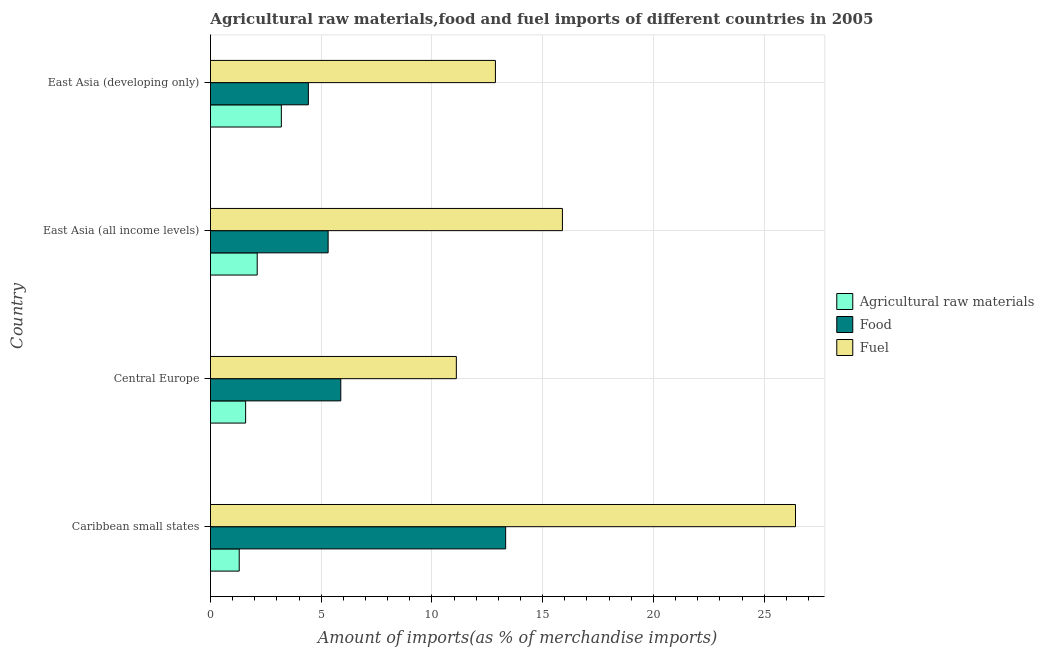Are the number of bars per tick equal to the number of legend labels?
Provide a succinct answer. Yes. How many bars are there on the 3rd tick from the top?
Offer a terse response. 3. How many bars are there on the 3rd tick from the bottom?
Give a very brief answer. 3. What is the label of the 3rd group of bars from the top?
Your answer should be very brief. Central Europe. In how many cases, is the number of bars for a given country not equal to the number of legend labels?
Your answer should be compact. 0. What is the percentage of raw materials imports in Central Europe?
Your response must be concise. 1.59. Across all countries, what is the maximum percentage of fuel imports?
Offer a terse response. 26.41. Across all countries, what is the minimum percentage of raw materials imports?
Your answer should be very brief. 1.3. In which country was the percentage of fuel imports maximum?
Give a very brief answer. Caribbean small states. In which country was the percentage of fuel imports minimum?
Give a very brief answer. Central Europe. What is the total percentage of raw materials imports in the graph?
Give a very brief answer. 8.19. What is the difference between the percentage of raw materials imports in East Asia (all income levels) and that in East Asia (developing only)?
Give a very brief answer. -1.09. What is the difference between the percentage of food imports in Central Europe and the percentage of raw materials imports in East Asia (developing only)?
Make the answer very short. 2.68. What is the average percentage of food imports per country?
Your response must be concise. 7.24. What is the difference between the percentage of food imports and percentage of fuel imports in Central Europe?
Give a very brief answer. -5.22. What is the ratio of the percentage of food imports in Caribbean small states to that in East Asia (developing only)?
Give a very brief answer. 3.02. What is the difference between the highest and the second highest percentage of food imports?
Provide a short and direct response. 7.45. What is the difference between the highest and the lowest percentage of raw materials imports?
Offer a very short reply. 1.9. In how many countries, is the percentage of fuel imports greater than the average percentage of fuel imports taken over all countries?
Ensure brevity in your answer.  1. Is the sum of the percentage of raw materials imports in Central Europe and East Asia (developing only) greater than the maximum percentage of fuel imports across all countries?
Your answer should be compact. No. What does the 2nd bar from the top in East Asia (developing only) represents?
Your answer should be very brief. Food. What does the 3rd bar from the bottom in Caribbean small states represents?
Your answer should be compact. Fuel. Are all the bars in the graph horizontal?
Provide a short and direct response. Yes. How many countries are there in the graph?
Keep it short and to the point. 4. Are the values on the major ticks of X-axis written in scientific E-notation?
Offer a terse response. No. Where does the legend appear in the graph?
Provide a succinct answer. Center right. What is the title of the graph?
Provide a succinct answer. Agricultural raw materials,food and fuel imports of different countries in 2005. What is the label or title of the X-axis?
Give a very brief answer. Amount of imports(as % of merchandise imports). What is the label or title of the Y-axis?
Your answer should be compact. Country. What is the Amount of imports(as % of merchandise imports) of Agricultural raw materials in Caribbean small states?
Make the answer very short. 1.3. What is the Amount of imports(as % of merchandise imports) of Food in Caribbean small states?
Your answer should be compact. 13.33. What is the Amount of imports(as % of merchandise imports) of Fuel in Caribbean small states?
Your response must be concise. 26.41. What is the Amount of imports(as % of merchandise imports) of Agricultural raw materials in Central Europe?
Your answer should be very brief. 1.59. What is the Amount of imports(as % of merchandise imports) of Food in Central Europe?
Ensure brevity in your answer.  5.88. What is the Amount of imports(as % of merchandise imports) in Fuel in Central Europe?
Provide a short and direct response. 11.1. What is the Amount of imports(as % of merchandise imports) of Agricultural raw materials in East Asia (all income levels)?
Make the answer very short. 2.11. What is the Amount of imports(as % of merchandise imports) in Food in East Asia (all income levels)?
Provide a succinct answer. 5.31. What is the Amount of imports(as % of merchandise imports) in Fuel in East Asia (all income levels)?
Your response must be concise. 15.89. What is the Amount of imports(as % of merchandise imports) of Agricultural raw materials in East Asia (developing only)?
Your response must be concise. 3.2. What is the Amount of imports(as % of merchandise imports) of Food in East Asia (developing only)?
Your answer should be very brief. 4.42. What is the Amount of imports(as % of merchandise imports) in Fuel in East Asia (developing only)?
Your answer should be compact. 12.87. Across all countries, what is the maximum Amount of imports(as % of merchandise imports) of Agricultural raw materials?
Provide a short and direct response. 3.2. Across all countries, what is the maximum Amount of imports(as % of merchandise imports) in Food?
Provide a short and direct response. 13.33. Across all countries, what is the maximum Amount of imports(as % of merchandise imports) of Fuel?
Provide a succinct answer. 26.41. Across all countries, what is the minimum Amount of imports(as % of merchandise imports) of Agricultural raw materials?
Provide a short and direct response. 1.3. Across all countries, what is the minimum Amount of imports(as % of merchandise imports) of Food?
Offer a terse response. 4.42. Across all countries, what is the minimum Amount of imports(as % of merchandise imports) in Fuel?
Your response must be concise. 11.1. What is the total Amount of imports(as % of merchandise imports) of Agricultural raw materials in the graph?
Provide a succinct answer. 8.19. What is the total Amount of imports(as % of merchandise imports) in Food in the graph?
Your response must be concise. 28.94. What is the total Amount of imports(as % of merchandise imports) in Fuel in the graph?
Your answer should be very brief. 66.27. What is the difference between the Amount of imports(as % of merchandise imports) of Agricultural raw materials in Caribbean small states and that in Central Europe?
Provide a succinct answer. -0.29. What is the difference between the Amount of imports(as % of merchandise imports) in Food in Caribbean small states and that in Central Europe?
Provide a succinct answer. 7.44. What is the difference between the Amount of imports(as % of merchandise imports) in Fuel in Caribbean small states and that in Central Europe?
Keep it short and to the point. 15.31. What is the difference between the Amount of imports(as % of merchandise imports) of Agricultural raw materials in Caribbean small states and that in East Asia (all income levels)?
Provide a succinct answer. -0.81. What is the difference between the Amount of imports(as % of merchandise imports) of Food in Caribbean small states and that in East Asia (all income levels)?
Offer a very short reply. 8.02. What is the difference between the Amount of imports(as % of merchandise imports) in Fuel in Caribbean small states and that in East Asia (all income levels)?
Your response must be concise. 10.52. What is the difference between the Amount of imports(as % of merchandise imports) of Agricultural raw materials in Caribbean small states and that in East Asia (developing only)?
Provide a succinct answer. -1.9. What is the difference between the Amount of imports(as % of merchandise imports) of Food in Caribbean small states and that in East Asia (developing only)?
Keep it short and to the point. 8.91. What is the difference between the Amount of imports(as % of merchandise imports) in Fuel in Caribbean small states and that in East Asia (developing only)?
Give a very brief answer. 13.55. What is the difference between the Amount of imports(as % of merchandise imports) of Agricultural raw materials in Central Europe and that in East Asia (all income levels)?
Provide a short and direct response. -0.52. What is the difference between the Amount of imports(as % of merchandise imports) of Food in Central Europe and that in East Asia (all income levels)?
Provide a short and direct response. 0.57. What is the difference between the Amount of imports(as % of merchandise imports) in Fuel in Central Europe and that in East Asia (all income levels)?
Offer a very short reply. -4.79. What is the difference between the Amount of imports(as % of merchandise imports) in Agricultural raw materials in Central Europe and that in East Asia (developing only)?
Provide a succinct answer. -1.61. What is the difference between the Amount of imports(as % of merchandise imports) of Food in Central Europe and that in East Asia (developing only)?
Make the answer very short. 1.46. What is the difference between the Amount of imports(as % of merchandise imports) in Fuel in Central Europe and that in East Asia (developing only)?
Make the answer very short. -1.76. What is the difference between the Amount of imports(as % of merchandise imports) in Agricultural raw materials in East Asia (all income levels) and that in East Asia (developing only)?
Make the answer very short. -1.09. What is the difference between the Amount of imports(as % of merchandise imports) in Food in East Asia (all income levels) and that in East Asia (developing only)?
Your answer should be compact. 0.89. What is the difference between the Amount of imports(as % of merchandise imports) in Fuel in East Asia (all income levels) and that in East Asia (developing only)?
Give a very brief answer. 3.03. What is the difference between the Amount of imports(as % of merchandise imports) of Agricultural raw materials in Caribbean small states and the Amount of imports(as % of merchandise imports) of Food in Central Europe?
Give a very brief answer. -4.59. What is the difference between the Amount of imports(as % of merchandise imports) in Agricultural raw materials in Caribbean small states and the Amount of imports(as % of merchandise imports) in Fuel in Central Europe?
Offer a terse response. -9.8. What is the difference between the Amount of imports(as % of merchandise imports) in Food in Caribbean small states and the Amount of imports(as % of merchandise imports) in Fuel in Central Europe?
Give a very brief answer. 2.23. What is the difference between the Amount of imports(as % of merchandise imports) in Agricultural raw materials in Caribbean small states and the Amount of imports(as % of merchandise imports) in Food in East Asia (all income levels)?
Make the answer very short. -4.01. What is the difference between the Amount of imports(as % of merchandise imports) of Agricultural raw materials in Caribbean small states and the Amount of imports(as % of merchandise imports) of Fuel in East Asia (all income levels)?
Offer a very short reply. -14.59. What is the difference between the Amount of imports(as % of merchandise imports) of Food in Caribbean small states and the Amount of imports(as % of merchandise imports) of Fuel in East Asia (all income levels)?
Your answer should be very brief. -2.56. What is the difference between the Amount of imports(as % of merchandise imports) in Agricultural raw materials in Caribbean small states and the Amount of imports(as % of merchandise imports) in Food in East Asia (developing only)?
Offer a terse response. -3.12. What is the difference between the Amount of imports(as % of merchandise imports) in Agricultural raw materials in Caribbean small states and the Amount of imports(as % of merchandise imports) in Fuel in East Asia (developing only)?
Give a very brief answer. -11.57. What is the difference between the Amount of imports(as % of merchandise imports) in Food in Caribbean small states and the Amount of imports(as % of merchandise imports) in Fuel in East Asia (developing only)?
Your response must be concise. 0.46. What is the difference between the Amount of imports(as % of merchandise imports) in Agricultural raw materials in Central Europe and the Amount of imports(as % of merchandise imports) in Food in East Asia (all income levels)?
Ensure brevity in your answer.  -3.73. What is the difference between the Amount of imports(as % of merchandise imports) in Agricultural raw materials in Central Europe and the Amount of imports(as % of merchandise imports) in Fuel in East Asia (all income levels)?
Ensure brevity in your answer.  -14.3. What is the difference between the Amount of imports(as % of merchandise imports) in Food in Central Europe and the Amount of imports(as % of merchandise imports) in Fuel in East Asia (all income levels)?
Offer a terse response. -10.01. What is the difference between the Amount of imports(as % of merchandise imports) of Agricultural raw materials in Central Europe and the Amount of imports(as % of merchandise imports) of Food in East Asia (developing only)?
Your response must be concise. -2.83. What is the difference between the Amount of imports(as % of merchandise imports) in Agricultural raw materials in Central Europe and the Amount of imports(as % of merchandise imports) in Fuel in East Asia (developing only)?
Provide a short and direct response. -11.28. What is the difference between the Amount of imports(as % of merchandise imports) in Food in Central Europe and the Amount of imports(as % of merchandise imports) in Fuel in East Asia (developing only)?
Provide a succinct answer. -6.98. What is the difference between the Amount of imports(as % of merchandise imports) in Agricultural raw materials in East Asia (all income levels) and the Amount of imports(as % of merchandise imports) in Food in East Asia (developing only)?
Your answer should be compact. -2.31. What is the difference between the Amount of imports(as % of merchandise imports) in Agricultural raw materials in East Asia (all income levels) and the Amount of imports(as % of merchandise imports) in Fuel in East Asia (developing only)?
Your response must be concise. -10.76. What is the difference between the Amount of imports(as % of merchandise imports) in Food in East Asia (all income levels) and the Amount of imports(as % of merchandise imports) in Fuel in East Asia (developing only)?
Your answer should be compact. -7.55. What is the average Amount of imports(as % of merchandise imports) in Agricultural raw materials per country?
Keep it short and to the point. 2.05. What is the average Amount of imports(as % of merchandise imports) of Food per country?
Provide a short and direct response. 7.24. What is the average Amount of imports(as % of merchandise imports) in Fuel per country?
Provide a short and direct response. 16.57. What is the difference between the Amount of imports(as % of merchandise imports) in Agricultural raw materials and Amount of imports(as % of merchandise imports) in Food in Caribbean small states?
Provide a succinct answer. -12.03. What is the difference between the Amount of imports(as % of merchandise imports) in Agricultural raw materials and Amount of imports(as % of merchandise imports) in Fuel in Caribbean small states?
Your answer should be very brief. -25.12. What is the difference between the Amount of imports(as % of merchandise imports) of Food and Amount of imports(as % of merchandise imports) of Fuel in Caribbean small states?
Your answer should be very brief. -13.09. What is the difference between the Amount of imports(as % of merchandise imports) of Agricultural raw materials and Amount of imports(as % of merchandise imports) of Food in Central Europe?
Provide a succinct answer. -4.3. What is the difference between the Amount of imports(as % of merchandise imports) of Agricultural raw materials and Amount of imports(as % of merchandise imports) of Fuel in Central Europe?
Provide a short and direct response. -9.51. What is the difference between the Amount of imports(as % of merchandise imports) in Food and Amount of imports(as % of merchandise imports) in Fuel in Central Europe?
Your answer should be very brief. -5.22. What is the difference between the Amount of imports(as % of merchandise imports) in Agricultural raw materials and Amount of imports(as % of merchandise imports) in Food in East Asia (all income levels)?
Offer a very short reply. -3.2. What is the difference between the Amount of imports(as % of merchandise imports) of Agricultural raw materials and Amount of imports(as % of merchandise imports) of Fuel in East Asia (all income levels)?
Your answer should be very brief. -13.78. What is the difference between the Amount of imports(as % of merchandise imports) of Food and Amount of imports(as % of merchandise imports) of Fuel in East Asia (all income levels)?
Give a very brief answer. -10.58. What is the difference between the Amount of imports(as % of merchandise imports) in Agricultural raw materials and Amount of imports(as % of merchandise imports) in Food in East Asia (developing only)?
Provide a succinct answer. -1.22. What is the difference between the Amount of imports(as % of merchandise imports) of Agricultural raw materials and Amount of imports(as % of merchandise imports) of Fuel in East Asia (developing only)?
Your answer should be compact. -9.67. What is the difference between the Amount of imports(as % of merchandise imports) of Food and Amount of imports(as % of merchandise imports) of Fuel in East Asia (developing only)?
Ensure brevity in your answer.  -8.45. What is the ratio of the Amount of imports(as % of merchandise imports) in Agricultural raw materials in Caribbean small states to that in Central Europe?
Give a very brief answer. 0.82. What is the ratio of the Amount of imports(as % of merchandise imports) of Food in Caribbean small states to that in Central Europe?
Make the answer very short. 2.27. What is the ratio of the Amount of imports(as % of merchandise imports) in Fuel in Caribbean small states to that in Central Europe?
Your answer should be very brief. 2.38. What is the ratio of the Amount of imports(as % of merchandise imports) in Agricultural raw materials in Caribbean small states to that in East Asia (all income levels)?
Offer a terse response. 0.62. What is the ratio of the Amount of imports(as % of merchandise imports) in Food in Caribbean small states to that in East Asia (all income levels)?
Give a very brief answer. 2.51. What is the ratio of the Amount of imports(as % of merchandise imports) in Fuel in Caribbean small states to that in East Asia (all income levels)?
Keep it short and to the point. 1.66. What is the ratio of the Amount of imports(as % of merchandise imports) in Agricultural raw materials in Caribbean small states to that in East Asia (developing only)?
Ensure brevity in your answer.  0.41. What is the ratio of the Amount of imports(as % of merchandise imports) in Food in Caribbean small states to that in East Asia (developing only)?
Your answer should be compact. 3.02. What is the ratio of the Amount of imports(as % of merchandise imports) of Fuel in Caribbean small states to that in East Asia (developing only)?
Keep it short and to the point. 2.05. What is the ratio of the Amount of imports(as % of merchandise imports) in Agricultural raw materials in Central Europe to that in East Asia (all income levels)?
Offer a terse response. 0.75. What is the ratio of the Amount of imports(as % of merchandise imports) in Food in Central Europe to that in East Asia (all income levels)?
Offer a terse response. 1.11. What is the ratio of the Amount of imports(as % of merchandise imports) in Fuel in Central Europe to that in East Asia (all income levels)?
Your answer should be very brief. 0.7. What is the ratio of the Amount of imports(as % of merchandise imports) in Agricultural raw materials in Central Europe to that in East Asia (developing only)?
Ensure brevity in your answer.  0.5. What is the ratio of the Amount of imports(as % of merchandise imports) in Food in Central Europe to that in East Asia (developing only)?
Give a very brief answer. 1.33. What is the ratio of the Amount of imports(as % of merchandise imports) in Fuel in Central Europe to that in East Asia (developing only)?
Your answer should be compact. 0.86. What is the ratio of the Amount of imports(as % of merchandise imports) in Agricultural raw materials in East Asia (all income levels) to that in East Asia (developing only)?
Offer a very short reply. 0.66. What is the ratio of the Amount of imports(as % of merchandise imports) of Food in East Asia (all income levels) to that in East Asia (developing only)?
Offer a very short reply. 1.2. What is the ratio of the Amount of imports(as % of merchandise imports) of Fuel in East Asia (all income levels) to that in East Asia (developing only)?
Give a very brief answer. 1.24. What is the difference between the highest and the second highest Amount of imports(as % of merchandise imports) in Agricultural raw materials?
Give a very brief answer. 1.09. What is the difference between the highest and the second highest Amount of imports(as % of merchandise imports) in Food?
Offer a terse response. 7.44. What is the difference between the highest and the second highest Amount of imports(as % of merchandise imports) of Fuel?
Offer a very short reply. 10.52. What is the difference between the highest and the lowest Amount of imports(as % of merchandise imports) in Agricultural raw materials?
Your answer should be compact. 1.9. What is the difference between the highest and the lowest Amount of imports(as % of merchandise imports) in Food?
Provide a succinct answer. 8.91. What is the difference between the highest and the lowest Amount of imports(as % of merchandise imports) of Fuel?
Keep it short and to the point. 15.31. 